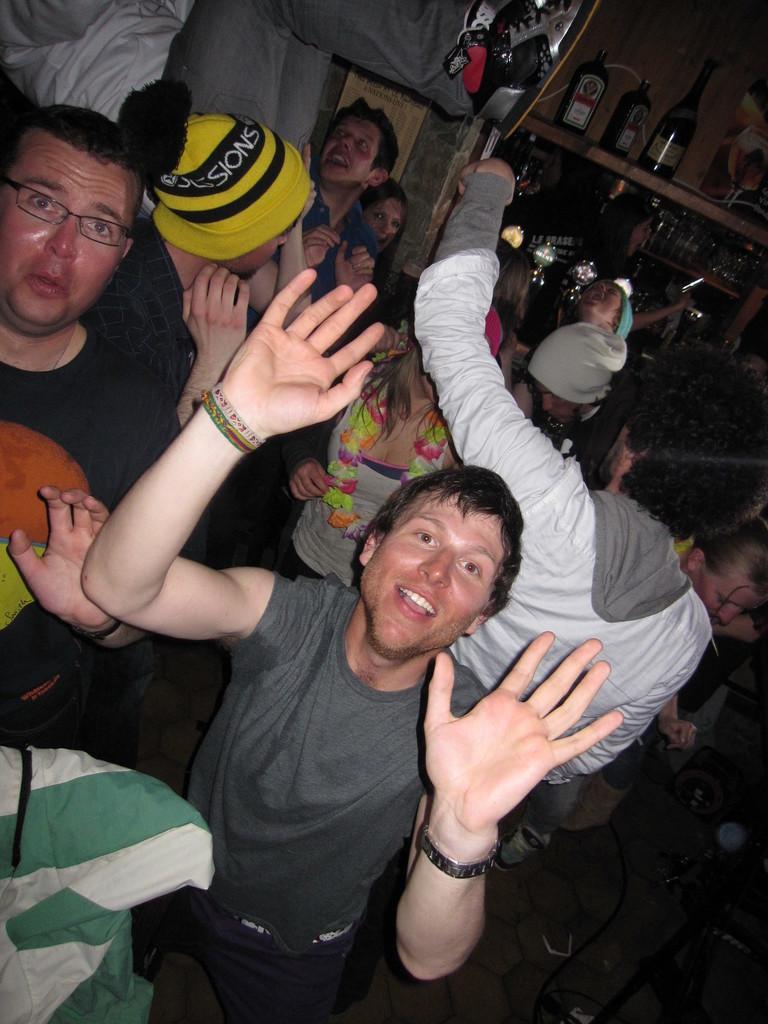In one or two sentences, can you explain what this image depicts? In this image we can see group of persons standing on the floor. One person is wearing a yellow cap. In the background, we can see group of bottles placed on the rack. 